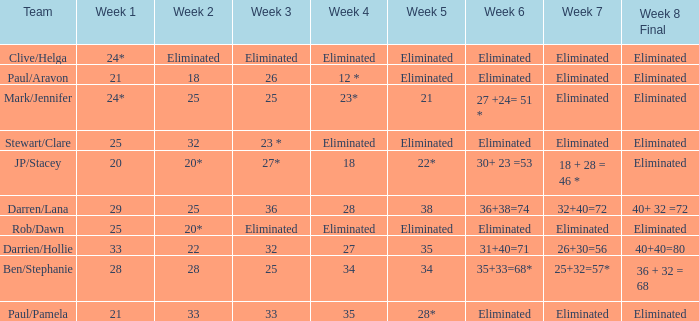Name the week 3 of 36 29.0. 